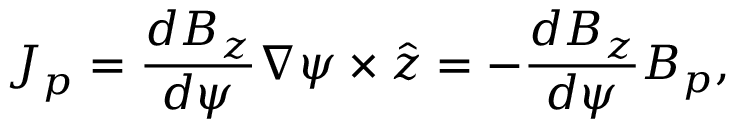Convert formula to latex. <formula><loc_0><loc_0><loc_500><loc_500>J _ { p } = \frac { d B _ { z } } { d \psi } \nabla \psi \times \hat { z } = - \frac { d B _ { z } } { d \psi } B _ { p } ,</formula> 